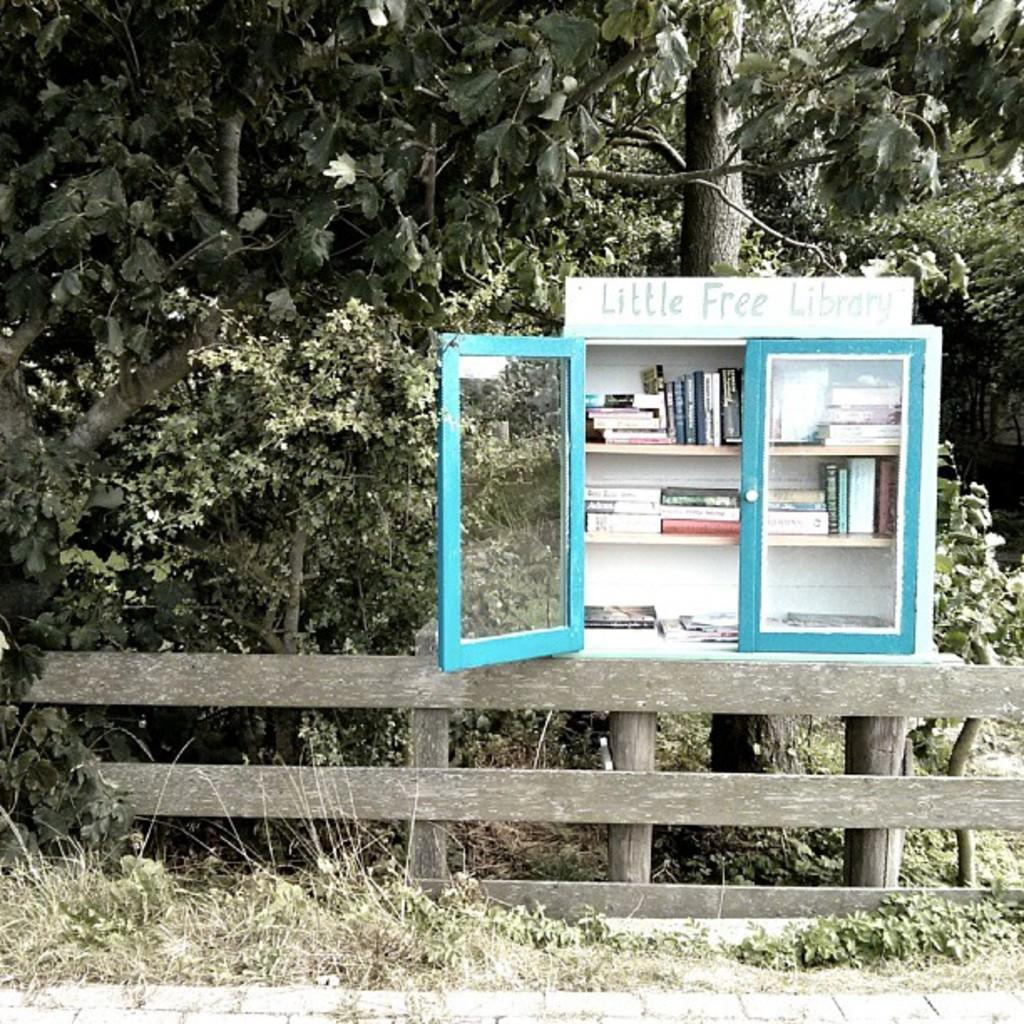<image>
Write a terse but informative summary of the picture. A little Free Library cabinet with blue doors is attached to the top of a wooden fence. 